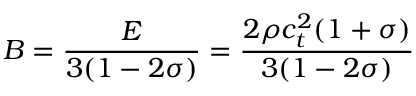Convert formula to latex. <formula><loc_0><loc_0><loc_500><loc_500>B = \frac { E } { 3 ( 1 - 2 \sigma ) } = \frac { 2 \rho c _ { t } ^ { 2 } ( 1 + \sigma ) } { 3 ( 1 - 2 \sigma ) }</formula> 